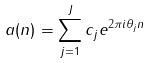Convert formula to latex. <formula><loc_0><loc_0><loc_500><loc_500>a ( n ) = \sum _ { j = 1 } ^ { J } c _ { j } e ^ { 2 \pi i \theta _ { j } n }</formula> 